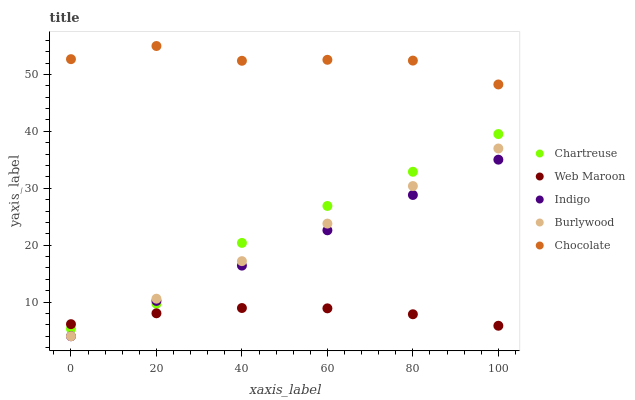Does Web Maroon have the minimum area under the curve?
Answer yes or no. Yes. Does Chocolate have the maximum area under the curve?
Answer yes or no. Yes. Does Indigo have the minimum area under the curve?
Answer yes or no. No. Does Indigo have the maximum area under the curve?
Answer yes or no. No. Is Burlywood the smoothest?
Answer yes or no. Yes. Is Chocolate the roughest?
Answer yes or no. Yes. Is Indigo the smoothest?
Answer yes or no. No. Is Indigo the roughest?
Answer yes or no. No. Does Burlywood have the lowest value?
Answer yes or no. Yes. Does Chartreuse have the lowest value?
Answer yes or no. No. Does Chocolate have the highest value?
Answer yes or no. Yes. Does Indigo have the highest value?
Answer yes or no. No. Is Burlywood less than Chocolate?
Answer yes or no. Yes. Is Chocolate greater than Burlywood?
Answer yes or no. Yes. Does Indigo intersect Burlywood?
Answer yes or no. Yes. Is Indigo less than Burlywood?
Answer yes or no. No. Is Indigo greater than Burlywood?
Answer yes or no. No. Does Burlywood intersect Chocolate?
Answer yes or no. No. 